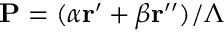Convert formula to latex. <formula><loc_0><loc_0><loc_500><loc_500>P = ( \alpha r ^ { \prime } + \beta r ^ { \prime \prime } ) / \Lambda</formula> 